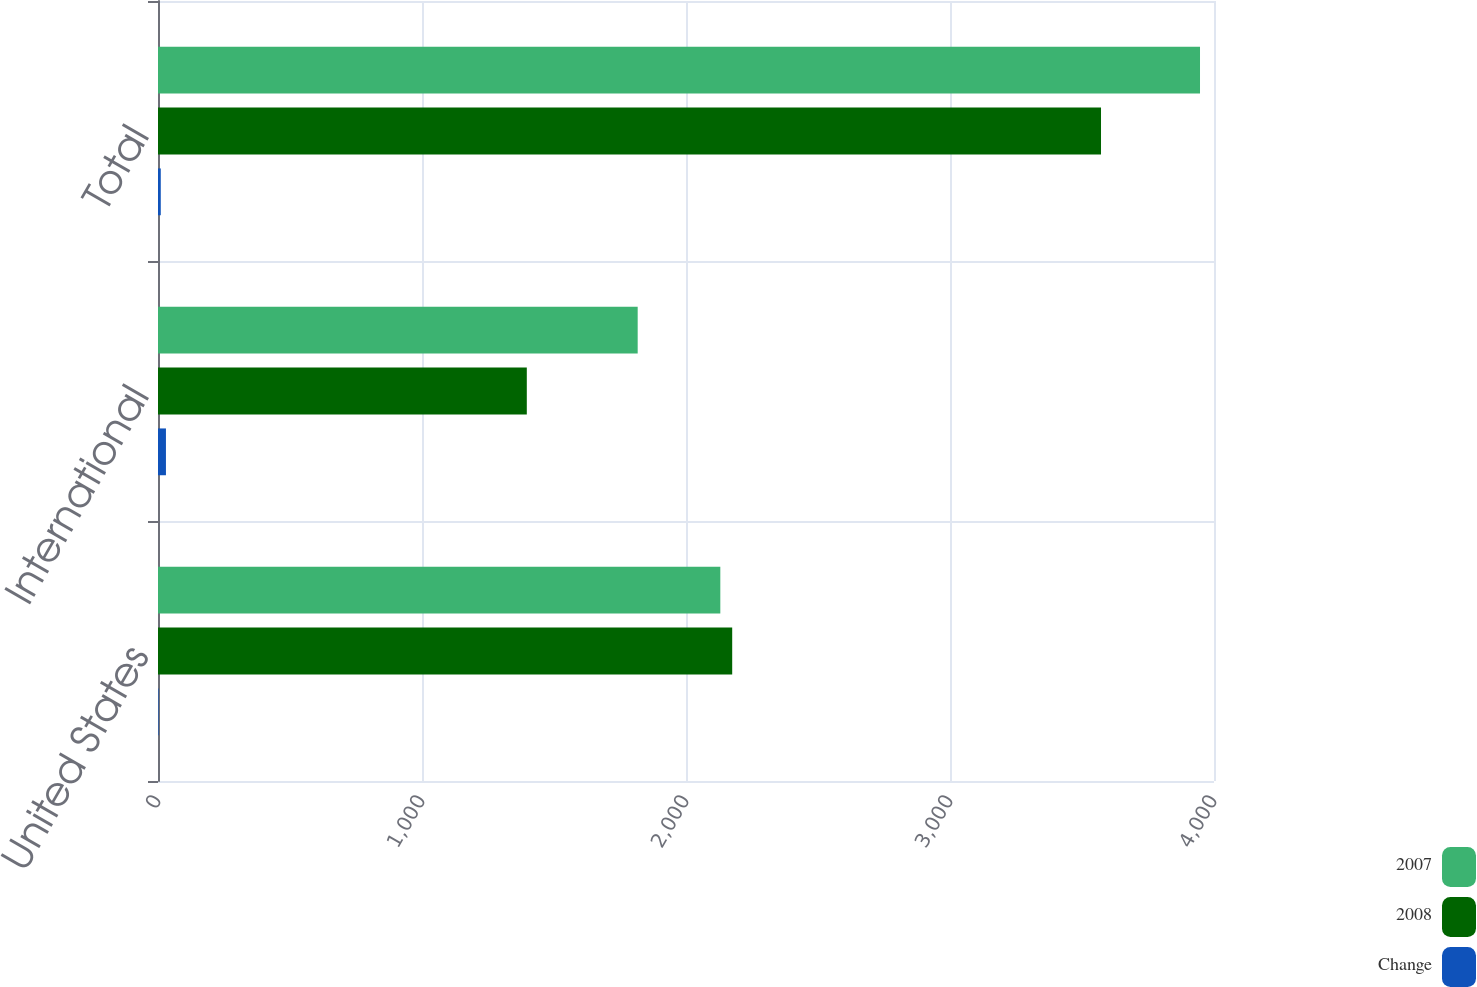<chart> <loc_0><loc_0><loc_500><loc_500><stacked_bar_chart><ecel><fcel>United States<fcel>International<fcel>Total<nl><fcel>2007<fcel>2130<fcel>1817<fcel>3947<nl><fcel>2008<fcel>2175<fcel>1397<fcel>3572<nl><fcel>Change<fcel>2.1<fcel>30.1<fcel>10.5<nl></chart> 